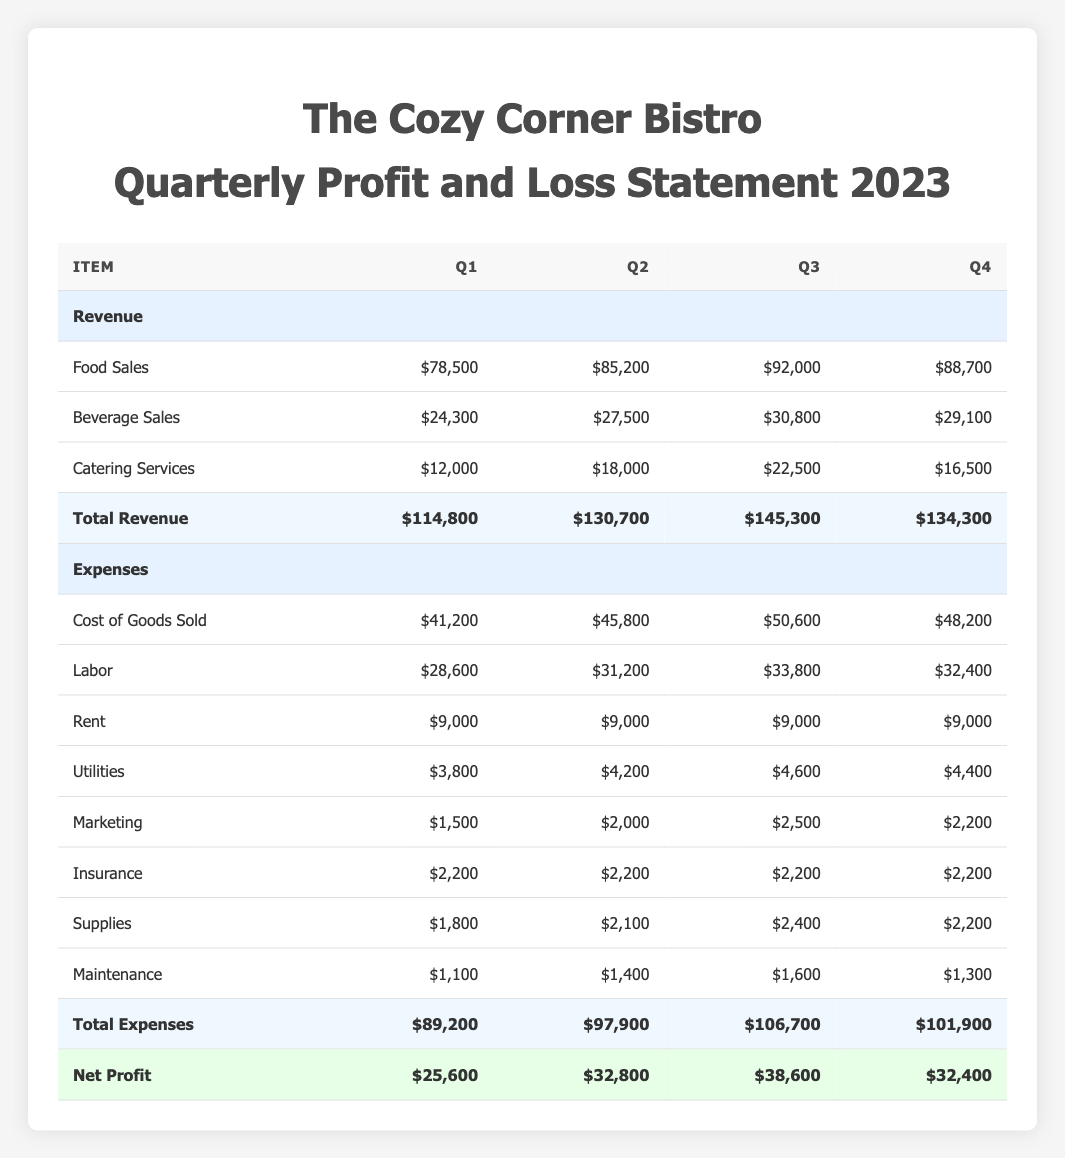What was the total revenue in Q3? By looking at the "Total Revenue" row in Q3, the value is $145,300.
Answer: $145,300 What is the highest revenue category in Q2? In Q2, the revenue categories are Food Sales ($85,200), Beverage Sales ($27,500), and Catering Services ($18,000). The highest is Food Sales at $85,200.
Answer: Food Sales Did the restaurant's net profit increase every quarter? The net profit for each quarter is $25,600 (Q1), $32,800 (Q2), $38,600 (Q3), and $32,400 (Q4). It increased in Q1 to Q3 but decreased from Q3 to Q4. Therefore, it did not increase every quarter.
Answer: No What is the difference in total expenses between Q1 and Q4? The total expenses in Q1 are $89,200 and in Q4 they are $101,900. To find the difference, subtract Q1 from Q4: $101,900 - $89,200 = $12,700.
Answer: $12,700 What was the average net profit across all quarters in 2023? The net profits are $25,600 (Q1), $32,800 (Q2), $38,600 (Q3), and $32,400 (Q4). Adding these gives $25,600 + $32,800 + $38,600 + $32,400 = $129,400. Dividing by 4 quarters gives an average of $129,400 / 4 = $32,350.
Answer: $32,350 Which quarter had the lowest labor expenses? The labor expenses for each quarter are: Q1 - $28,600, Q2 - $31,200, Q3 - $33,800, and Q4 - $32,400. Q1 has the lowest labor expenses at $28,600.
Answer: Q1 What is the total revenue for the year? To find the total revenue for the year, sum the total revenues of all four quarters: Q1 - $114,800, Q2 - $130,700, Q3 - $145,300, Q4 - $134,300. The total is $114,800 + $130,700 + $145,300 + $134,300 = $525,100.
Answer: $525,100 Was the rent expense consistent throughout the year? The rent expense for each quarter is $9,000 in Q1, Q2, Q3, and Q4. Since all values are the same, the rent expense was consistent throughout the year.
Answer: Yes How much more did the restaurant make in net profit in Q3 compared to Q1? The net profit in Q3 is $38,600 and in Q1 is $25,600. To find the difference, subtract Q1 from Q3: $38,600 - $25,600 = $13,000.
Answer: $13,000 